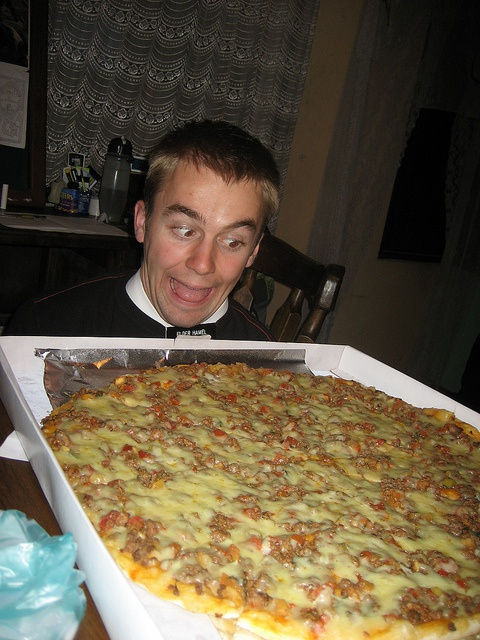Describe the objects in this image and their specific colors. I can see pizza in black, tan, and olive tones, people in black, brown, and maroon tones, chair in black and gray tones, dining table in black, maroon, and gray tones, and dining table in black and gray tones in this image. 